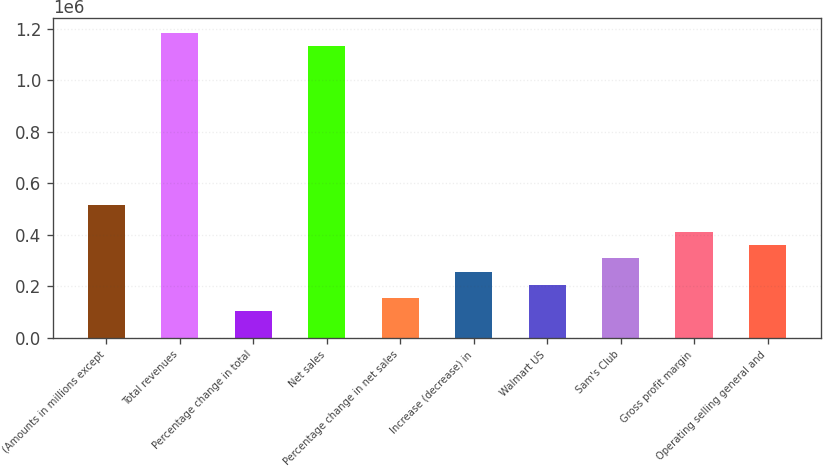<chart> <loc_0><loc_0><loc_500><loc_500><bar_chart><fcel>(Amounts in millions except<fcel>Total revenues<fcel>Percentage change in total<fcel>Net sales<fcel>Percentage change in net sales<fcel>Increase (decrease) in<fcel>Walmart US<fcel>Sam's Club<fcel>Gross profit margin<fcel>Operating selling general and<nl><fcel>514405<fcel>1.18313e+06<fcel>102883<fcel>1.13169e+06<fcel>154323<fcel>257204<fcel>205763<fcel>308644<fcel>411524<fcel>360084<nl></chart> 